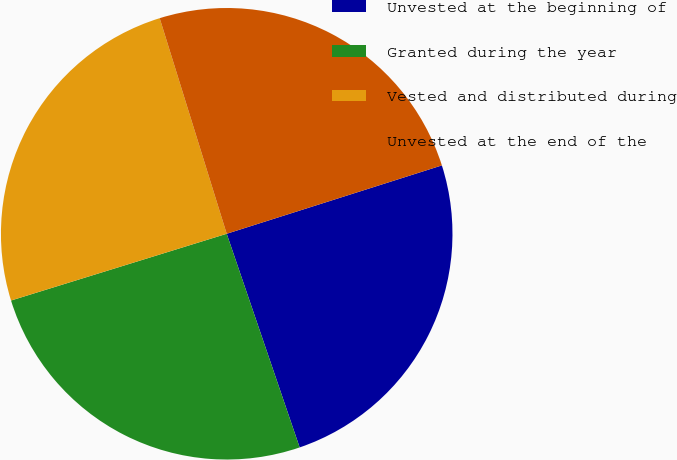Convert chart to OTSL. <chart><loc_0><loc_0><loc_500><loc_500><pie_chart><fcel>Unvested at the beginning of<fcel>Granted during the year<fcel>Vested and distributed during<fcel>Unvested at the end of the<nl><fcel>24.66%<fcel>25.46%<fcel>24.98%<fcel>24.9%<nl></chart> 